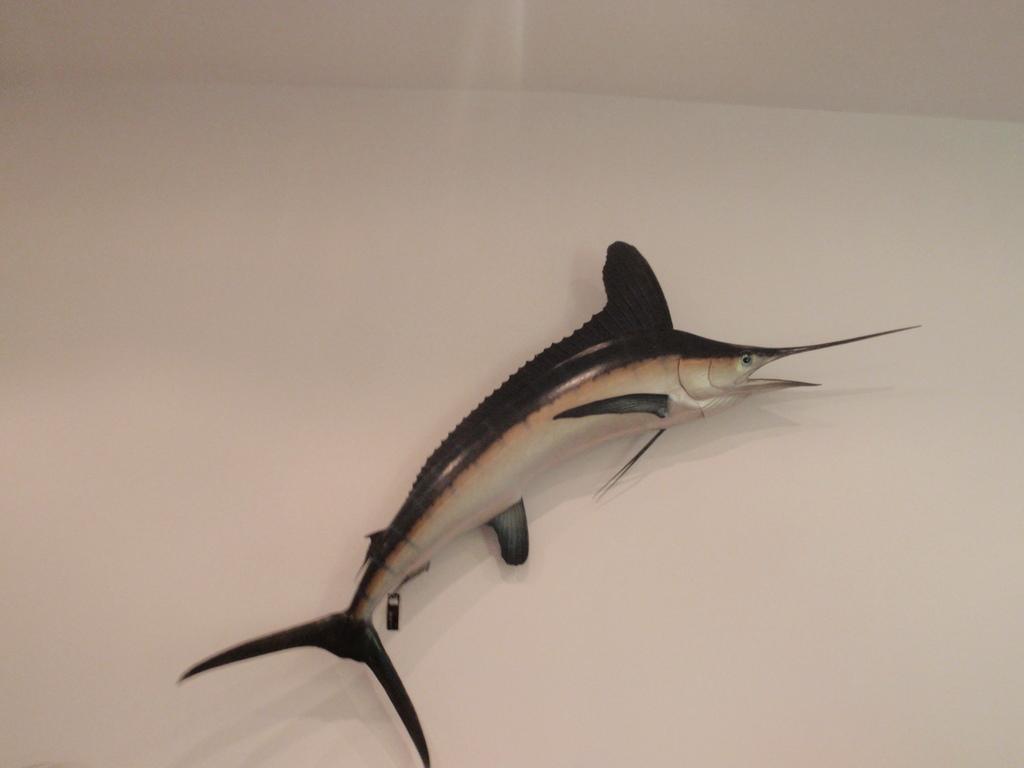Please provide a concise description of this image. In this image we can see a fish, it is in black color, here is the eye, here is the mouth. 